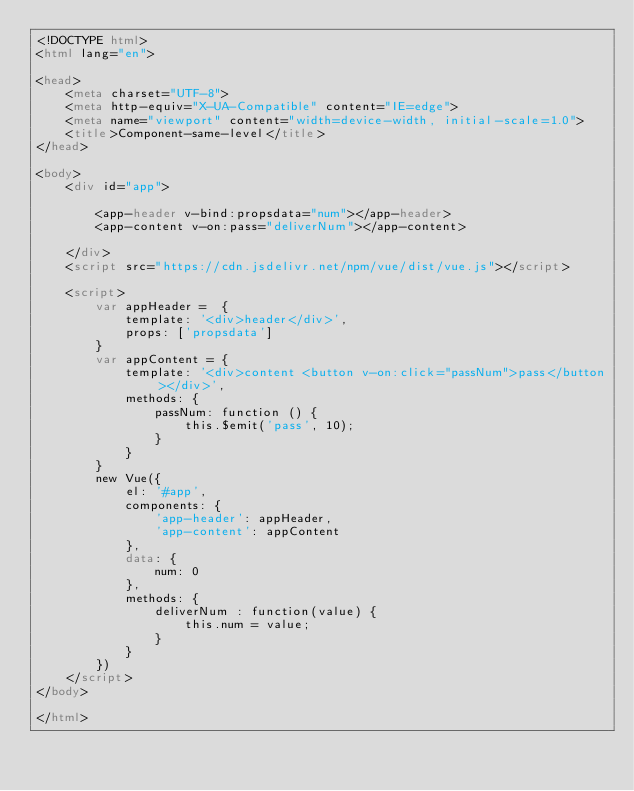Convert code to text. <code><loc_0><loc_0><loc_500><loc_500><_HTML_><!DOCTYPE html>
<html lang="en">

<head>
    <meta charset="UTF-8">
    <meta http-equiv="X-UA-Compatible" content="IE=edge">
    <meta name="viewport" content="width=device-width, initial-scale=1.0">
    <title>Component-same-level</title>
</head>

<body>
    <div id="app">

        <app-header v-bind:propsdata="num"></app-header>
        <app-content v-on:pass="deliverNum"></app-content>
        
    </div>
    <script src="https://cdn.jsdelivr.net/npm/vue/dist/vue.js"></script>

    <script>
        var appHeader =  {
            template: '<div>header</div>',
            props: ['propsdata']
        }
        var appContent = {
            template: '<div>content <button v-on:click="passNum">pass</button></div>',
            methods: {
                passNum: function () {
                    this.$emit('pass', 10);
                }
            }
        }
        new Vue({
            el: '#app',
            components: {
                'app-header': appHeader,
                'app-content': appContent
            },
            data: {
                num: 0
            },
            methods: {
                deliverNum : function(value) {
                    this.num = value;
                }
            }
        })
    </script>
</body>

</html></code> 